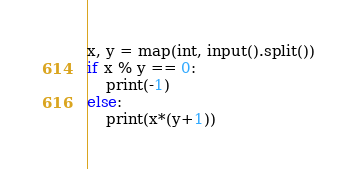<code> <loc_0><loc_0><loc_500><loc_500><_Python_>x, y = map(int, input().split())
if x % y == 0:
    print(-1)
else:
    print(x*(y+1))
</code> 